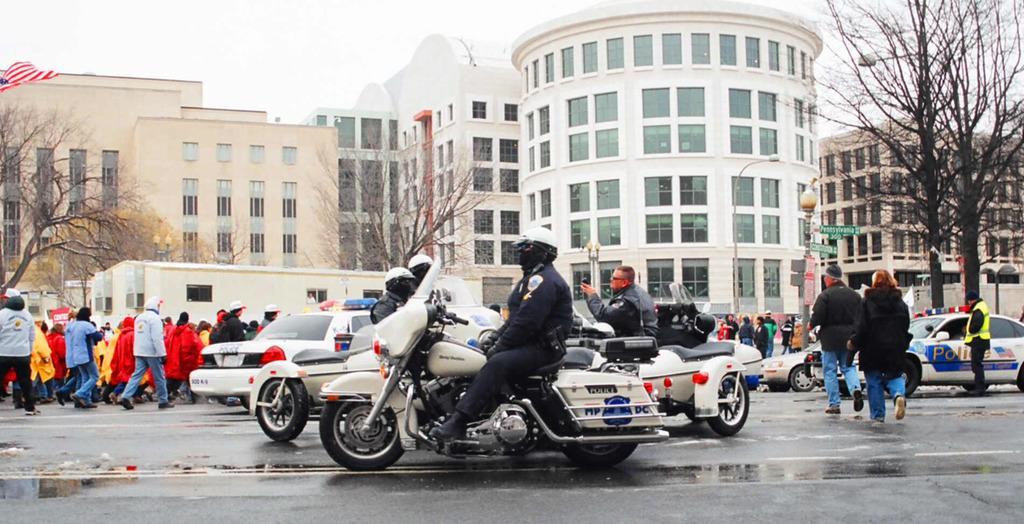How would you summarize this image in a sentence or two? In this image we can see the police vehicles on the road. We can also see the policeman. In the background we can see many people walking on the road. We can also see the buildings, trees, light pole and some other pole with information boards. Sky is also visible. On the left there is a flag. 